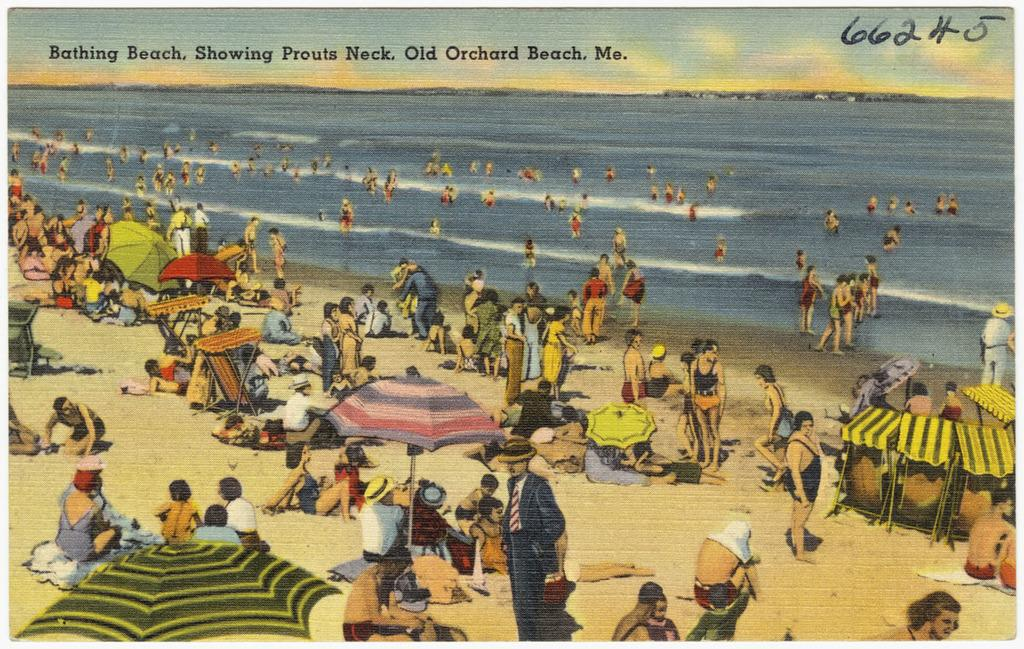Provide a one-sentence caption for the provided image. Postcard from a Bathing Beach in Old Orchard Beach in Maine. 